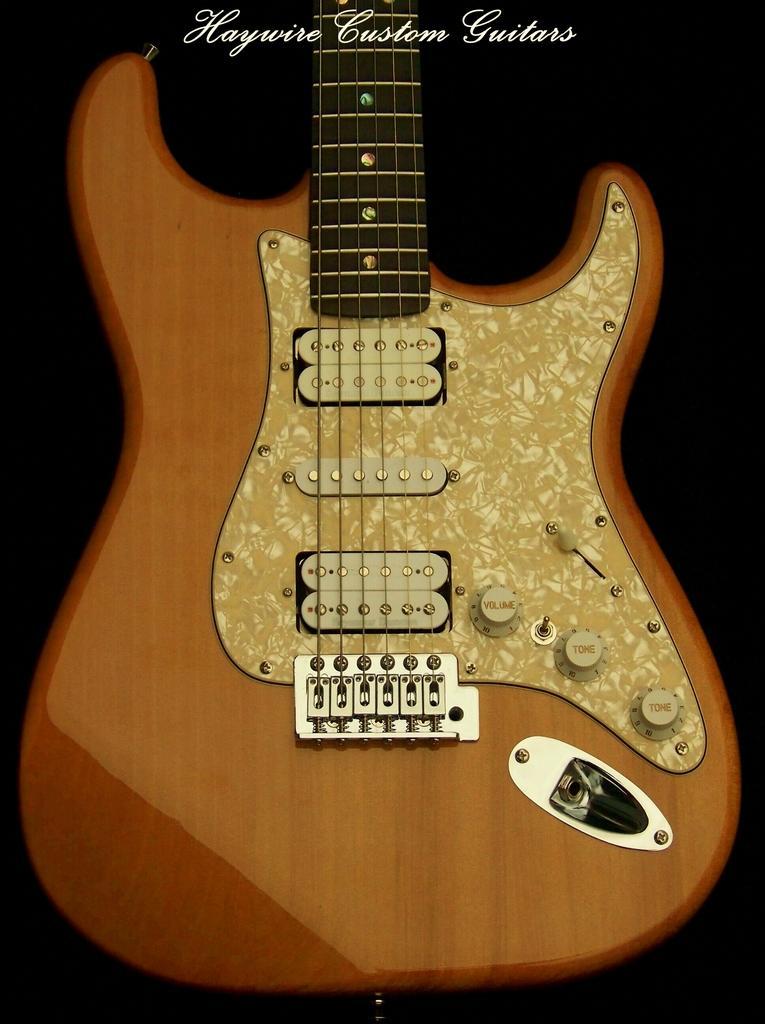In one or two sentences, can you explain what this image depicts? in this image there is a guitar. above that haywire custom guitars are written. 